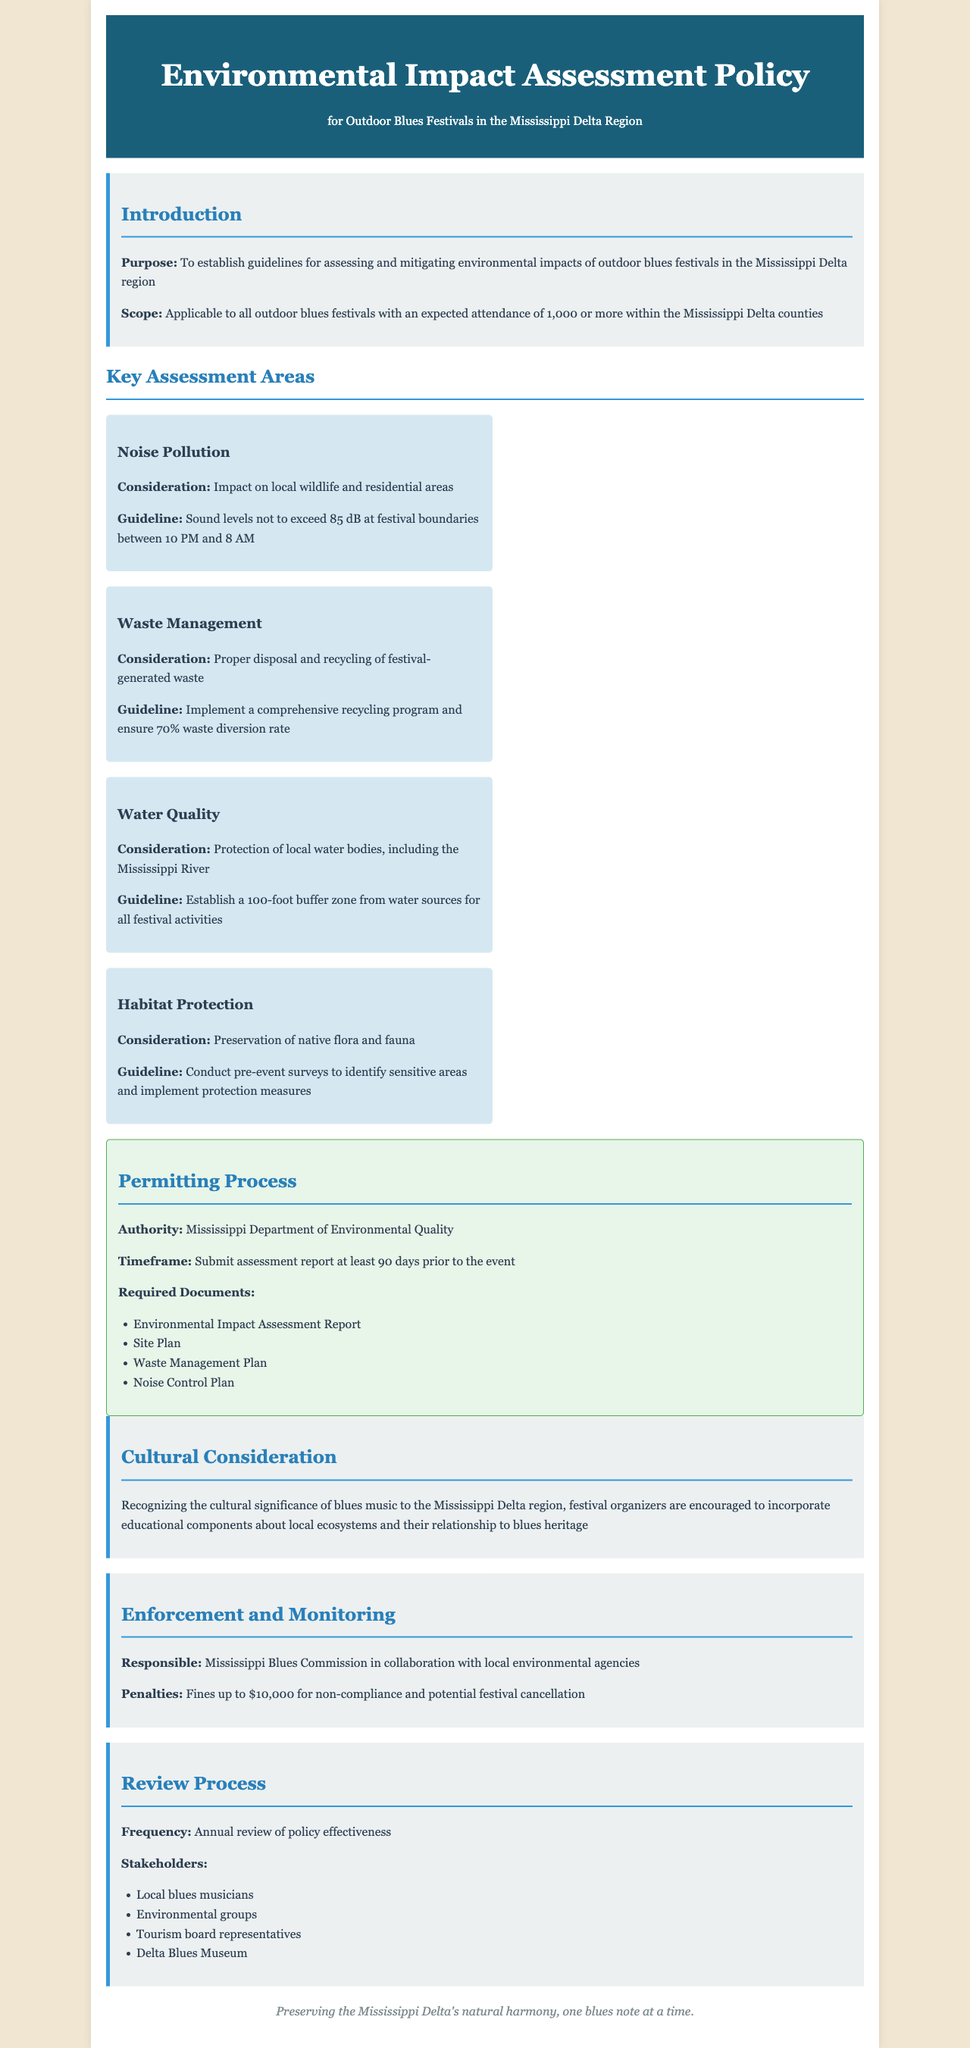What is the purpose of the policy? The policy's purpose is to establish guidelines for assessing and mitigating environmental impacts of outdoor blues festivals in the Mississippi Delta region.
Answer: To establish guidelines for assessing and mitigating environmental impacts of outdoor blues festivals in the Mississippi Delta region What is the expected attendance to trigger the policy? The policy is applicable to all outdoor blues festivals with this expected attendance.
Answer: 1,000 or more Which department has the authority over the permitting process? The permitting authority details are specified in the document.
Answer: Mississippi Department of Environmental Quality What is the maximum noise level allowed between 10 PM and 8 AM? The guideline specifies sound levels in relation to noise pollution.
Answer: 85 dB What is the required waste diversion rate? This figure indicates the effectiveness desired for waste management at festivals.
Answer: 70% Who collaborates with the Mississippi Blues Commission for enforcement? This detail lists organizations involved in the enforcement of the policy.
Answer: Local environmental agencies What is the penalty for non-compliance with the policy? The consequences for not adhering to the policy are outlined in the enforcement section.
Answer: $10,000 What is included in the required documents for the permitting process? The section delineates several key documents that must be submitted.
Answer: Environmental Impact Assessment Report, Site Plan, Waste Management Plan, Noise Control Plan When should the assessment report be submitted? The timeframe for submitting the assessment report is clear in the permitting process section.
Answer: 90 days prior to the event 